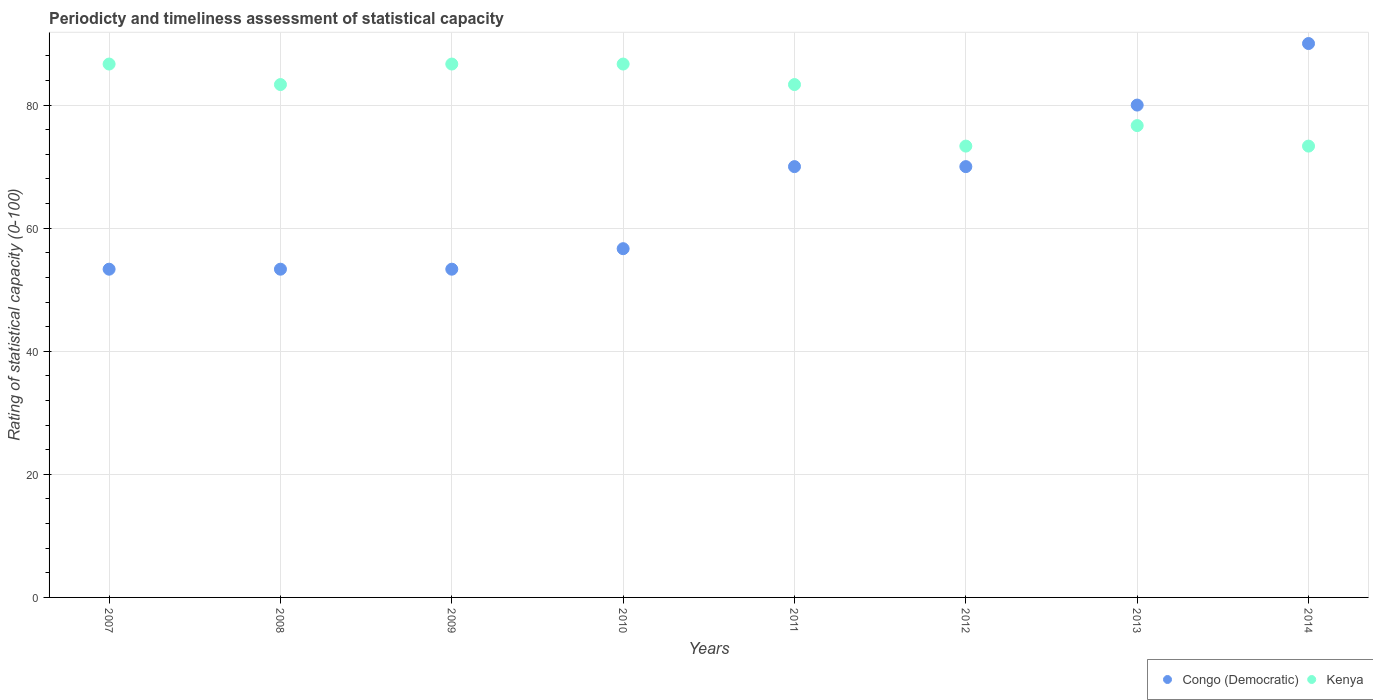How many different coloured dotlines are there?
Your response must be concise. 2. Is the number of dotlines equal to the number of legend labels?
Your response must be concise. Yes. What is the rating of statistical capacity in Kenya in 2012?
Provide a short and direct response. 73.33. Across all years, what is the maximum rating of statistical capacity in Kenya?
Make the answer very short. 86.67. Across all years, what is the minimum rating of statistical capacity in Congo (Democratic)?
Your answer should be compact. 53.33. In which year was the rating of statistical capacity in Congo (Democratic) minimum?
Your answer should be very brief. 2007. What is the total rating of statistical capacity in Kenya in the graph?
Give a very brief answer. 650. What is the difference between the rating of statistical capacity in Congo (Democratic) in 2009 and that in 2012?
Your answer should be very brief. -16.67. What is the difference between the rating of statistical capacity in Kenya in 2011 and the rating of statistical capacity in Congo (Democratic) in 2010?
Offer a terse response. 26.67. What is the average rating of statistical capacity in Congo (Democratic) per year?
Give a very brief answer. 65.83. In the year 2011, what is the difference between the rating of statistical capacity in Kenya and rating of statistical capacity in Congo (Democratic)?
Ensure brevity in your answer.  13.33. What is the ratio of the rating of statistical capacity in Kenya in 2011 to that in 2013?
Your answer should be very brief. 1.09. Is the rating of statistical capacity in Congo (Democratic) in 2007 less than that in 2013?
Your answer should be very brief. Yes. Is the difference between the rating of statistical capacity in Kenya in 2009 and 2010 greater than the difference between the rating of statistical capacity in Congo (Democratic) in 2009 and 2010?
Give a very brief answer. Yes. What is the difference between the highest and the lowest rating of statistical capacity in Congo (Democratic)?
Make the answer very short. 36.67. In how many years, is the rating of statistical capacity in Congo (Democratic) greater than the average rating of statistical capacity in Congo (Democratic) taken over all years?
Make the answer very short. 4. Does the rating of statistical capacity in Congo (Democratic) monotonically increase over the years?
Keep it short and to the point. No. Is the rating of statistical capacity in Congo (Democratic) strictly less than the rating of statistical capacity in Kenya over the years?
Your answer should be very brief. No. Are the values on the major ticks of Y-axis written in scientific E-notation?
Ensure brevity in your answer.  No. Where does the legend appear in the graph?
Make the answer very short. Bottom right. How many legend labels are there?
Your answer should be very brief. 2. What is the title of the graph?
Your answer should be very brief. Periodicty and timeliness assessment of statistical capacity. What is the label or title of the X-axis?
Your response must be concise. Years. What is the label or title of the Y-axis?
Give a very brief answer. Rating of statistical capacity (0-100). What is the Rating of statistical capacity (0-100) in Congo (Democratic) in 2007?
Offer a terse response. 53.33. What is the Rating of statistical capacity (0-100) of Kenya in 2007?
Offer a terse response. 86.67. What is the Rating of statistical capacity (0-100) in Congo (Democratic) in 2008?
Your answer should be very brief. 53.33. What is the Rating of statistical capacity (0-100) in Kenya in 2008?
Provide a succinct answer. 83.33. What is the Rating of statistical capacity (0-100) of Congo (Democratic) in 2009?
Provide a succinct answer. 53.33. What is the Rating of statistical capacity (0-100) of Kenya in 2009?
Provide a succinct answer. 86.67. What is the Rating of statistical capacity (0-100) of Congo (Democratic) in 2010?
Make the answer very short. 56.67. What is the Rating of statistical capacity (0-100) in Kenya in 2010?
Your answer should be very brief. 86.67. What is the Rating of statistical capacity (0-100) of Kenya in 2011?
Provide a short and direct response. 83.33. What is the Rating of statistical capacity (0-100) in Kenya in 2012?
Make the answer very short. 73.33. What is the Rating of statistical capacity (0-100) in Kenya in 2013?
Your answer should be very brief. 76.67. What is the Rating of statistical capacity (0-100) in Congo (Democratic) in 2014?
Ensure brevity in your answer.  90. What is the Rating of statistical capacity (0-100) of Kenya in 2014?
Provide a succinct answer. 73.33. Across all years, what is the maximum Rating of statistical capacity (0-100) in Congo (Democratic)?
Give a very brief answer. 90. Across all years, what is the maximum Rating of statistical capacity (0-100) in Kenya?
Your answer should be compact. 86.67. Across all years, what is the minimum Rating of statistical capacity (0-100) in Congo (Democratic)?
Ensure brevity in your answer.  53.33. Across all years, what is the minimum Rating of statistical capacity (0-100) in Kenya?
Your answer should be compact. 73.33. What is the total Rating of statistical capacity (0-100) of Congo (Democratic) in the graph?
Keep it short and to the point. 526.67. What is the total Rating of statistical capacity (0-100) of Kenya in the graph?
Your answer should be compact. 650. What is the difference between the Rating of statistical capacity (0-100) of Congo (Democratic) in 2007 and that in 2008?
Offer a very short reply. 0. What is the difference between the Rating of statistical capacity (0-100) of Kenya in 2007 and that in 2008?
Offer a very short reply. 3.33. What is the difference between the Rating of statistical capacity (0-100) in Congo (Democratic) in 2007 and that in 2009?
Offer a very short reply. 0. What is the difference between the Rating of statistical capacity (0-100) in Kenya in 2007 and that in 2010?
Your answer should be very brief. 0. What is the difference between the Rating of statistical capacity (0-100) of Congo (Democratic) in 2007 and that in 2011?
Give a very brief answer. -16.67. What is the difference between the Rating of statistical capacity (0-100) of Kenya in 2007 and that in 2011?
Give a very brief answer. 3.33. What is the difference between the Rating of statistical capacity (0-100) in Congo (Democratic) in 2007 and that in 2012?
Offer a very short reply. -16.67. What is the difference between the Rating of statistical capacity (0-100) of Kenya in 2007 and that in 2012?
Offer a terse response. 13.33. What is the difference between the Rating of statistical capacity (0-100) of Congo (Democratic) in 2007 and that in 2013?
Keep it short and to the point. -26.67. What is the difference between the Rating of statistical capacity (0-100) of Congo (Democratic) in 2007 and that in 2014?
Offer a very short reply. -36.67. What is the difference between the Rating of statistical capacity (0-100) of Kenya in 2007 and that in 2014?
Give a very brief answer. 13.33. What is the difference between the Rating of statistical capacity (0-100) of Congo (Democratic) in 2008 and that in 2009?
Your response must be concise. 0. What is the difference between the Rating of statistical capacity (0-100) of Kenya in 2008 and that in 2009?
Your answer should be compact. -3.33. What is the difference between the Rating of statistical capacity (0-100) in Congo (Democratic) in 2008 and that in 2010?
Keep it short and to the point. -3.33. What is the difference between the Rating of statistical capacity (0-100) of Congo (Democratic) in 2008 and that in 2011?
Your answer should be compact. -16.67. What is the difference between the Rating of statistical capacity (0-100) of Kenya in 2008 and that in 2011?
Offer a terse response. 0. What is the difference between the Rating of statistical capacity (0-100) of Congo (Democratic) in 2008 and that in 2012?
Make the answer very short. -16.67. What is the difference between the Rating of statistical capacity (0-100) of Kenya in 2008 and that in 2012?
Offer a very short reply. 10. What is the difference between the Rating of statistical capacity (0-100) of Congo (Democratic) in 2008 and that in 2013?
Offer a very short reply. -26.67. What is the difference between the Rating of statistical capacity (0-100) in Kenya in 2008 and that in 2013?
Your response must be concise. 6.67. What is the difference between the Rating of statistical capacity (0-100) in Congo (Democratic) in 2008 and that in 2014?
Provide a succinct answer. -36.67. What is the difference between the Rating of statistical capacity (0-100) in Kenya in 2008 and that in 2014?
Provide a succinct answer. 10. What is the difference between the Rating of statistical capacity (0-100) of Congo (Democratic) in 2009 and that in 2011?
Keep it short and to the point. -16.67. What is the difference between the Rating of statistical capacity (0-100) of Congo (Democratic) in 2009 and that in 2012?
Your response must be concise. -16.67. What is the difference between the Rating of statistical capacity (0-100) of Kenya in 2009 and that in 2012?
Ensure brevity in your answer.  13.33. What is the difference between the Rating of statistical capacity (0-100) in Congo (Democratic) in 2009 and that in 2013?
Ensure brevity in your answer.  -26.67. What is the difference between the Rating of statistical capacity (0-100) in Congo (Democratic) in 2009 and that in 2014?
Ensure brevity in your answer.  -36.67. What is the difference between the Rating of statistical capacity (0-100) in Kenya in 2009 and that in 2014?
Your answer should be very brief. 13.33. What is the difference between the Rating of statistical capacity (0-100) of Congo (Democratic) in 2010 and that in 2011?
Provide a succinct answer. -13.33. What is the difference between the Rating of statistical capacity (0-100) of Congo (Democratic) in 2010 and that in 2012?
Offer a terse response. -13.33. What is the difference between the Rating of statistical capacity (0-100) of Kenya in 2010 and that in 2012?
Offer a very short reply. 13.33. What is the difference between the Rating of statistical capacity (0-100) of Congo (Democratic) in 2010 and that in 2013?
Ensure brevity in your answer.  -23.33. What is the difference between the Rating of statistical capacity (0-100) of Kenya in 2010 and that in 2013?
Offer a terse response. 10. What is the difference between the Rating of statistical capacity (0-100) in Congo (Democratic) in 2010 and that in 2014?
Your answer should be very brief. -33.33. What is the difference between the Rating of statistical capacity (0-100) of Kenya in 2010 and that in 2014?
Your response must be concise. 13.33. What is the difference between the Rating of statistical capacity (0-100) of Congo (Democratic) in 2011 and that in 2014?
Keep it short and to the point. -20. What is the difference between the Rating of statistical capacity (0-100) in Kenya in 2011 and that in 2014?
Make the answer very short. 10. What is the difference between the Rating of statistical capacity (0-100) in Kenya in 2012 and that in 2013?
Offer a very short reply. -3.33. What is the difference between the Rating of statistical capacity (0-100) in Congo (Democratic) in 2012 and that in 2014?
Offer a very short reply. -20. What is the difference between the Rating of statistical capacity (0-100) in Congo (Democratic) in 2013 and that in 2014?
Make the answer very short. -10. What is the difference between the Rating of statistical capacity (0-100) of Kenya in 2013 and that in 2014?
Provide a short and direct response. 3.33. What is the difference between the Rating of statistical capacity (0-100) of Congo (Democratic) in 2007 and the Rating of statistical capacity (0-100) of Kenya in 2008?
Ensure brevity in your answer.  -30. What is the difference between the Rating of statistical capacity (0-100) of Congo (Democratic) in 2007 and the Rating of statistical capacity (0-100) of Kenya in 2009?
Offer a terse response. -33.33. What is the difference between the Rating of statistical capacity (0-100) of Congo (Democratic) in 2007 and the Rating of statistical capacity (0-100) of Kenya in 2010?
Offer a terse response. -33.33. What is the difference between the Rating of statistical capacity (0-100) of Congo (Democratic) in 2007 and the Rating of statistical capacity (0-100) of Kenya in 2011?
Your answer should be very brief. -30. What is the difference between the Rating of statistical capacity (0-100) in Congo (Democratic) in 2007 and the Rating of statistical capacity (0-100) in Kenya in 2013?
Provide a succinct answer. -23.33. What is the difference between the Rating of statistical capacity (0-100) in Congo (Democratic) in 2007 and the Rating of statistical capacity (0-100) in Kenya in 2014?
Give a very brief answer. -20. What is the difference between the Rating of statistical capacity (0-100) of Congo (Democratic) in 2008 and the Rating of statistical capacity (0-100) of Kenya in 2009?
Your answer should be compact. -33.33. What is the difference between the Rating of statistical capacity (0-100) in Congo (Democratic) in 2008 and the Rating of statistical capacity (0-100) in Kenya in 2010?
Your answer should be very brief. -33.33. What is the difference between the Rating of statistical capacity (0-100) of Congo (Democratic) in 2008 and the Rating of statistical capacity (0-100) of Kenya in 2011?
Ensure brevity in your answer.  -30. What is the difference between the Rating of statistical capacity (0-100) in Congo (Democratic) in 2008 and the Rating of statistical capacity (0-100) in Kenya in 2012?
Keep it short and to the point. -20. What is the difference between the Rating of statistical capacity (0-100) of Congo (Democratic) in 2008 and the Rating of statistical capacity (0-100) of Kenya in 2013?
Make the answer very short. -23.33. What is the difference between the Rating of statistical capacity (0-100) in Congo (Democratic) in 2009 and the Rating of statistical capacity (0-100) in Kenya in 2010?
Provide a short and direct response. -33.33. What is the difference between the Rating of statistical capacity (0-100) in Congo (Democratic) in 2009 and the Rating of statistical capacity (0-100) in Kenya in 2012?
Ensure brevity in your answer.  -20. What is the difference between the Rating of statistical capacity (0-100) of Congo (Democratic) in 2009 and the Rating of statistical capacity (0-100) of Kenya in 2013?
Make the answer very short. -23.33. What is the difference between the Rating of statistical capacity (0-100) in Congo (Democratic) in 2009 and the Rating of statistical capacity (0-100) in Kenya in 2014?
Offer a terse response. -20. What is the difference between the Rating of statistical capacity (0-100) of Congo (Democratic) in 2010 and the Rating of statistical capacity (0-100) of Kenya in 2011?
Your response must be concise. -26.67. What is the difference between the Rating of statistical capacity (0-100) of Congo (Democratic) in 2010 and the Rating of statistical capacity (0-100) of Kenya in 2012?
Make the answer very short. -16.67. What is the difference between the Rating of statistical capacity (0-100) in Congo (Democratic) in 2010 and the Rating of statistical capacity (0-100) in Kenya in 2014?
Keep it short and to the point. -16.67. What is the difference between the Rating of statistical capacity (0-100) of Congo (Democratic) in 2011 and the Rating of statistical capacity (0-100) of Kenya in 2013?
Your answer should be very brief. -6.67. What is the difference between the Rating of statistical capacity (0-100) of Congo (Democratic) in 2012 and the Rating of statistical capacity (0-100) of Kenya in 2013?
Provide a short and direct response. -6.67. What is the average Rating of statistical capacity (0-100) of Congo (Democratic) per year?
Offer a terse response. 65.83. What is the average Rating of statistical capacity (0-100) in Kenya per year?
Keep it short and to the point. 81.25. In the year 2007, what is the difference between the Rating of statistical capacity (0-100) of Congo (Democratic) and Rating of statistical capacity (0-100) of Kenya?
Provide a short and direct response. -33.33. In the year 2008, what is the difference between the Rating of statistical capacity (0-100) of Congo (Democratic) and Rating of statistical capacity (0-100) of Kenya?
Provide a succinct answer. -30. In the year 2009, what is the difference between the Rating of statistical capacity (0-100) of Congo (Democratic) and Rating of statistical capacity (0-100) of Kenya?
Keep it short and to the point. -33.33. In the year 2010, what is the difference between the Rating of statistical capacity (0-100) of Congo (Democratic) and Rating of statistical capacity (0-100) of Kenya?
Provide a short and direct response. -30. In the year 2011, what is the difference between the Rating of statistical capacity (0-100) of Congo (Democratic) and Rating of statistical capacity (0-100) of Kenya?
Give a very brief answer. -13.33. In the year 2012, what is the difference between the Rating of statistical capacity (0-100) of Congo (Democratic) and Rating of statistical capacity (0-100) of Kenya?
Give a very brief answer. -3.33. In the year 2014, what is the difference between the Rating of statistical capacity (0-100) in Congo (Democratic) and Rating of statistical capacity (0-100) in Kenya?
Your response must be concise. 16.67. What is the ratio of the Rating of statistical capacity (0-100) of Congo (Democratic) in 2007 to that in 2008?
Provide a succinct answer. 1. What is the ratio of the Rating of statistical capacity (0-100) of Kenya in 2007 to that in 2008?
Your answer should be compact. 1.04. What is the ratio of the Rating of statistical capacity (0-100) of Congo (Democratic) in 2007 to that in 2009?
Ensure brevity in your answer.  1. What is the ratio of the Rating of statistical capacity (0-100) of Congo (Democratic) in 2007 to that in 2010?
Give a very brief answer. 0.94. What is the ratio of the Rating of statistical capacity (0-100) in Congo (Democratic) in 2007 to that in 2011?
Provide a succinct answer. 0.76. What is the ratio of the Rating of statistical capacity (0-100) of Congo (Democratic) in 2007 to that in 2012?
Give a very brief answer. 0.76. What is the ratio of the Rating of statistical capacity (0-100) of Kenya in 2007 to that in 2012?
Your answer should be very brief. 1.18. What is the ratio of the Rating of statistical capacity (0-100) of Congo (Democratic) in 2007 to that in 2013?
Offer a terse response. 0.67. What is the ratio of the Rating of statistical capacity (0-100) of Kenya in 2007 to that in 2013?
Your answer should be compact. 1.13. What is the ratio of the Rating of statistical capacity (0-100) of Congo (Democratic) in 2007 to that in 2014?
Your answer should be very brief. 0.59. What is the ratio of the Rating of statistical capacity (0-100) in Kenya in 2007 to that in 2014?
Make the answer very short. 1.18. What is the ratio of the Rating of statistical capacity (0-100) in Kenya in 2008 to that in 2009?
Provide a short and direct response. 0.96. What is the ratio of the Rating of statistical capacity (0-100) in Kenya in 2008 to that in 2010?
Your answer should be compact. 0.96. What is the ratio of the Rating of statistical capacity (0-100) in Congo (Democratic) in 2008 to that in 2011?
Your response must be concise. 0.76. What is the ratio of the Rating of statistical capacity (0-100) of Kenya in 2008 to that in 2011?
Ensure brevity in your answer.  1. What is the ratio of the Rating of statistical capacity (0-100) in Congo (Democratic) in 2008 to that in 2012?
Offer a terse response. 0.76. What is the ratio of the Rating of statistical capacity (0-100) in Kenya in 2008 to that in 2012?
Ensure brevity in your answer.  1.14. What is the ratio of the Rating of statistical capacity (0-100) in Kenya in 2008 to that in 2013?
Offer a terse response. 1.09. What is the ratio of the Rating of statistical capacity (0-100) of Congo (Democratic) in 2008 to that in 2014?
Keep it short and to the point. 0.59. What is the ratio of the Rating of statistical capacity (0-100) of Kenya in 2008 to that in 2014?
Your answer should be compact. 1.14. What is the ratio of the Rating of statistical capacity (0-100) of Congo (Democratic) in 2009 to that in 2011?
Offer a terse response. 0.76. What is the ratio of the Rating of statistical capacity (0-100) of Kenya in 2009 to that in 2011?
Keep it short and to the point. 1.04. What is the ratio of the Rating of statistical capacity (0-100) of Congo (Democratic) in 2009 to that in 2012?
Keep it short and to the point. 0.76. What is the ratio of the Rating of statistical capacity (0-100) in Kenya in 2009 to that in 2012?
Your answer should be compact. 1.18. What is the ratio of the Rating of statistical capacity (0-100) of Kenya in 2009 to that in 2013?
Give a very brief answer. 1.13. What is the ratio of the Rating of statistical capacity (0-100) of Congo (Democratic) in 2009 to that in 2014?
Ensure brevity in your answer.  0.59. What is the ratio of the Rating of statistical capacity (0-100) in Kenya in 2009 to that in 2014?
Make the answer very short. 1.18. What is the ratio of the Rating of statistical capacity (0-100) in Congo (Democratic) in 2010 to that in 2011?
Your response must be concise. 0.81. What is the ratio of the Rating of statistical capacity (0-100) of Kenya in 2010 to that in 2011?
Keep it short and to the point. 1.04. What is the ratio of the Rating of statistical capacity (0-100) in Congo (Democratic) in 2010 to that in 2012?
Provide a succinct answer. 0.81. What is the ratio of the Rating of statistical capacity (0-100) of Kenya in 2010 to that in 2012?
Make the answer very short. 1.18. What is the ratio of the Rating of statistical capacity (0-100) of Congo (Democratic) in 2010 to that in 2013?
Make the answer very short. 0.71. What is the ratio of the Rating of statistical capacity (0-100) in Kenya in 2010 to that in 2013?
Give a very brief answer. 1.13. What is the ratio of the Rating of statistical capacity (0-100) in Congo (Democratic) in 2010 to that in 2014?
Provide a short and direct response. 0.63. What is the ratio of the Rating of statistical capacity (0-100) in Kenya in 2010 to that in 2014?
Ensure brevity in your answer.  1.18. What is the ratio of the Rating of statistical capacity (0-100) in Congo (Democratic) in 2011 to that in 2012?
Provide a succinct answer. 1. What is the ratio of the Rating of statistical capacity (0-100) in Kenya in 2011 to that in 2012?
Ensure brevity in your answer.  1.14. What is the ratio of the Rating of statistical capacity (0-100) of Congo (Democratic) in 2011 to that in 2013?
Your response must be concise. 0.88. What is the ratio of the Rating of statistical capacity (0-100) of Kenya in 2011 to that in 2013?
Offer a very short reply. 1.09. What is the ratio of the Rating of statistical capacity (0-100) in Kenya in 2011 to that in 2014?
Give a very brief answer. 1.14. What is the ratio of the Rating of statistical capacity (0-100) of Kenya in 2012 to that in 2013?
Give a very brief answer. 0.96. What is the ratio of the Rating of statistical capacity (0-100) of Congo (Democratic) in 2012 to that in 2014?
Keep it short and to the point. 0.78. What is the ratio of the Rating of statistical capacity (0-100) in Kenya in 2012 to that in 2014?
Offer a very short reply. 1. What is the ratio of the Rating of statistical capacity (0-100) in Kenya in 2013 to that in 2014?
Keep it short and to the point. 1.05. What is the difference between the highest and the lowest Rating of statistical capacity (0-100) in Congo (Democratic)?
Your answer should be compact. 36.67. What is the difference between the highest and the lowest Rating of statistical capacity (0-100) of Kenya?
Keep it short and to the point. 13.33. 